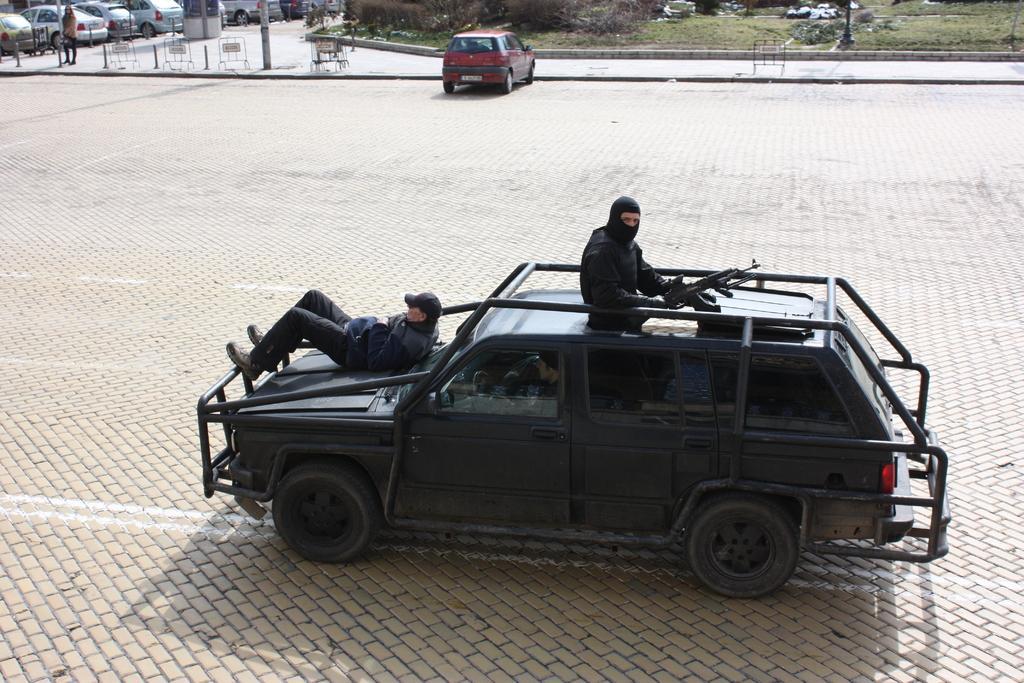Please provide a concise description of this image. In this image there is one vehicle in the bottom of this image and there are two persons are on this vehicle as we can see in middle of this image. There are some cars on the top of this image. There is a floor ground in the middle of this image. There is one person standing on the top left corner of this image. 